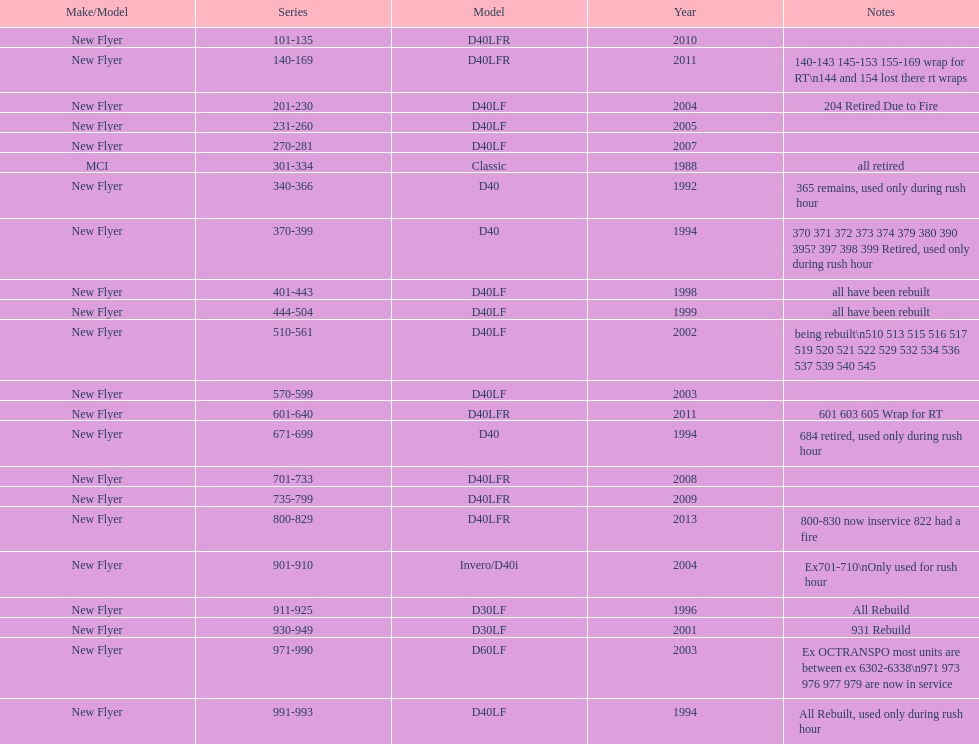Which buses are the newest in the existing fleet? 800-829. 